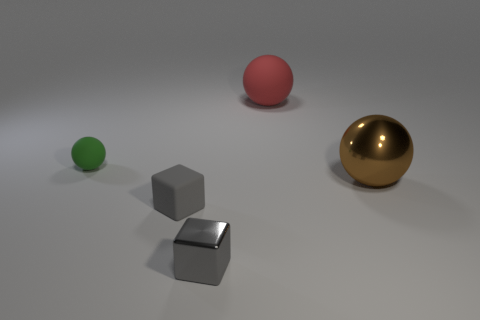Add 4 tiny green metal cylinders. How many objects exist? 9 Subtract all spheres. How many objects are left? 2 Subtract all small purple rubber cubes. Subtract all green objects. How many objects are left? 4 Add 5 brown shiny spheres. How many brown shiny spheres are left? 6 Add 4 green rubber balls. How many green rubber balls exist? 5 Subtract 0 red blocks. How many objects are left? 5 